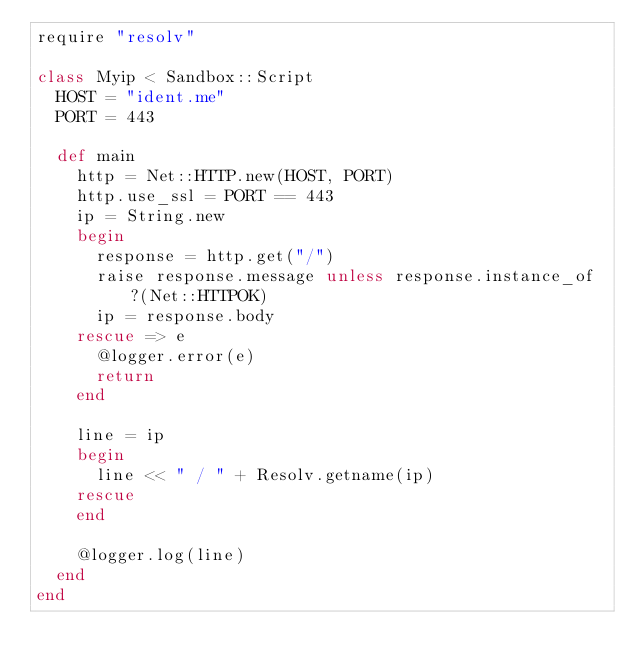<code> <loc_0><loc_0><loc_500><loc_500><_Ruby_>require "resolv"

class Myip < Sandbox::Script
  HOST = "ident.me"
  PORT = 443

  def main
    http = Net::HTTP.new(HOST, PORT)
    http.use_ssl = PORT == 443
    ip = String.new
    begin
      response = http.get("/")
      raise response.message unless response.instance_of?(Net::HTTPOK)
      ip = response.body
    rescue => e
      @logger.error(e)
      return
    end

    line = ip
    begin
      line << " / " + Resolv.getname(ip)
    rescue
    end

    @logger.log(line)
  end
end

</code> 